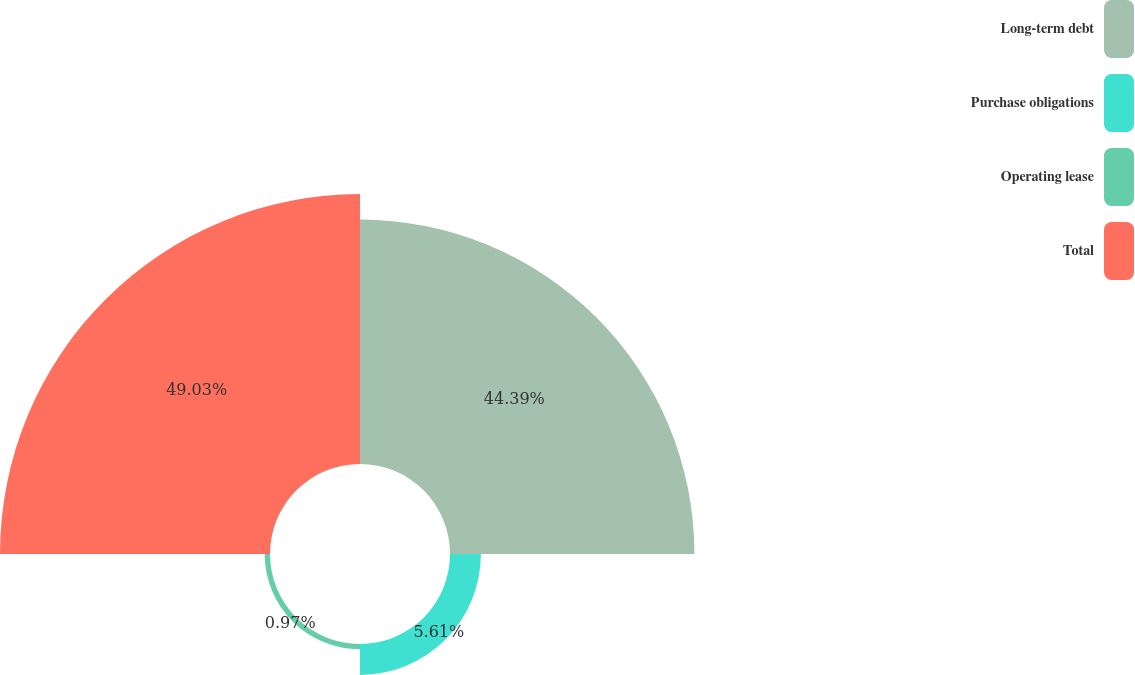Convert chart. <chart><loc_0><loc_0><loc_500><loc_500><pie_chart><fcel>Long-term debt<fcel>Purchase obligations<fcel>Operating lease<fcel>Total<nl><fcel>44.39%<fcel>5.61%<fcel>0.97%<fcel>49.03%<nl></chart> 